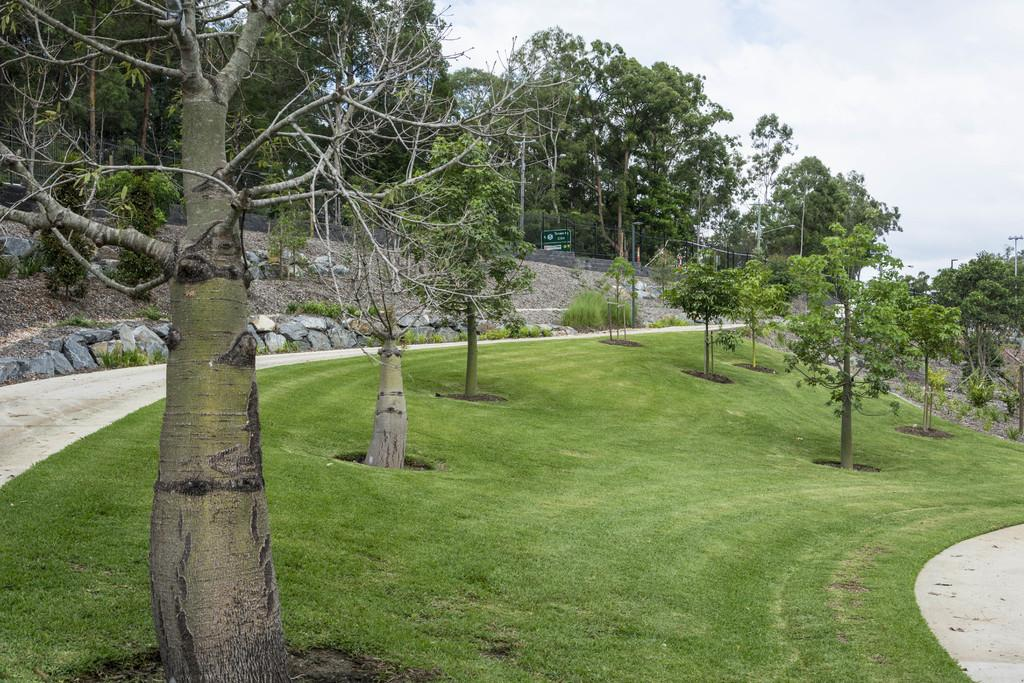What type of vegetation can be seen in the image? There are trees and grass in the image. Are there any paths visible in the image? Yes, there are paths on the left and right sides of the image. What can be seen in the background of the image? In the background, there are trees, poles, stones, a hoarding, and clouds in the sky. What type of bulb is used to light up the trees in the image? There are no bulbs present in the image; the trees are illuminated by natural sunlight. What type of plant is depicted on the hoarding in the background of the image? There is no plant depicted on the hoarding in the image; it features a different subject or message. 